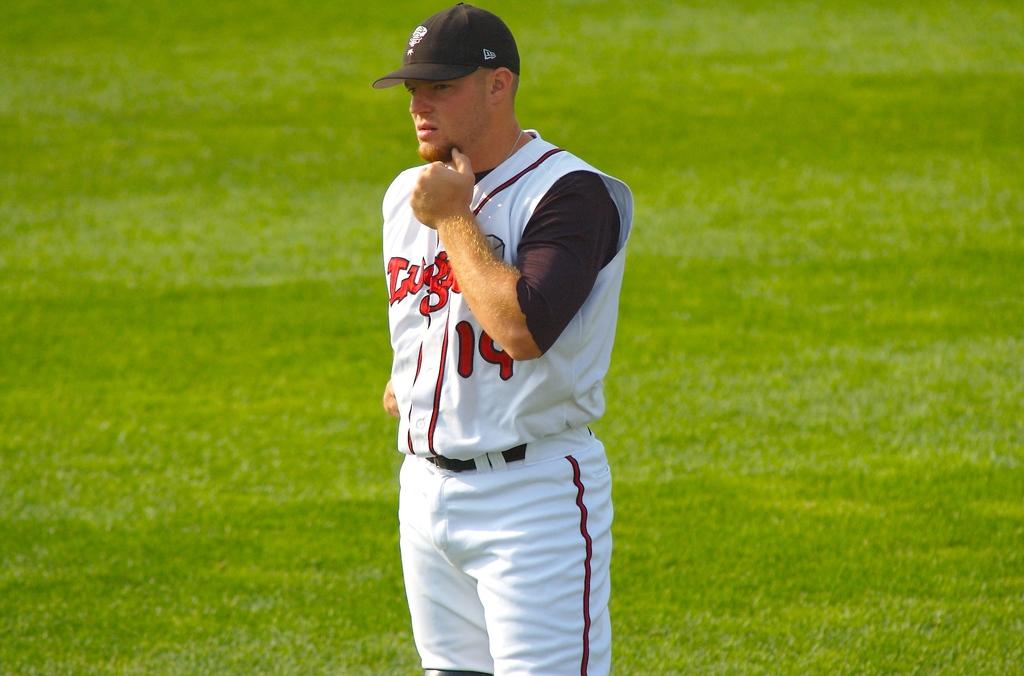What number is he?
Your answer should be very brief. 14. 